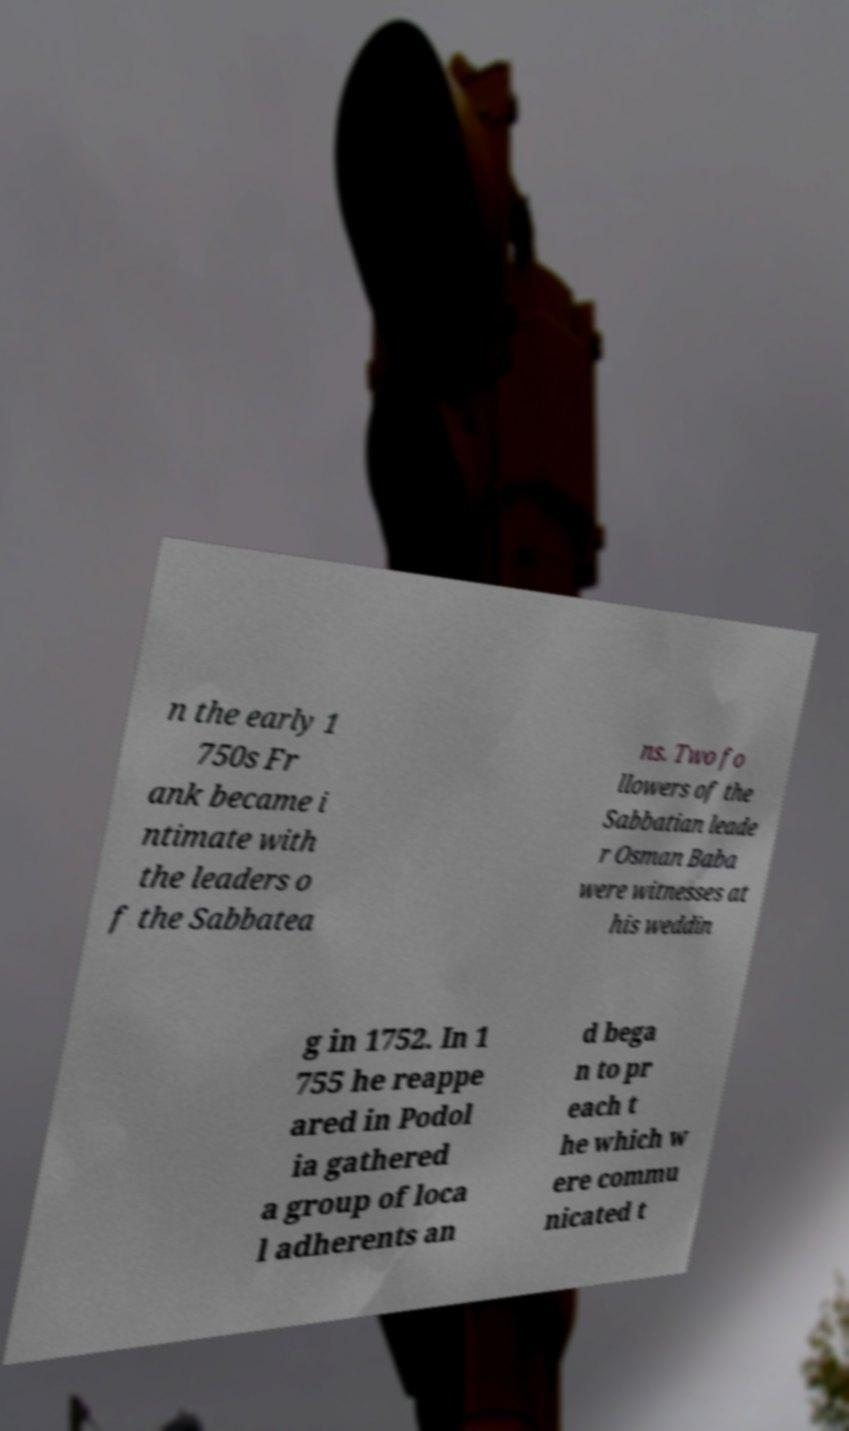Please identify and transcribe the text found in this image. n the early 1 750s Fr ank became i ntimate with the leaders o f the Sabbatea ns. Two fo llowers of the Sabbatian leade r Osman Baba were witnesses at his weddin g in 1752. In 1 755 he reappe ared in Podol ia gathered a group of loca l adherents an d bega n to pr each t he which w ere commu nicated t 